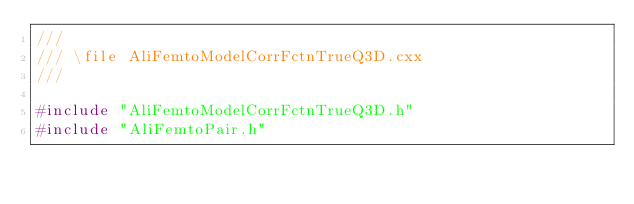<code> <loc_0><loc_0><loc_500><loc_500><_C++_>///
/// \file AliFemtoModelCorrFctnTrueQ3D.cxx
///

#include "AliFemtoModelCorrFctnTrueQ3D.h"
#include "AliFemtoPair.h"</code> 